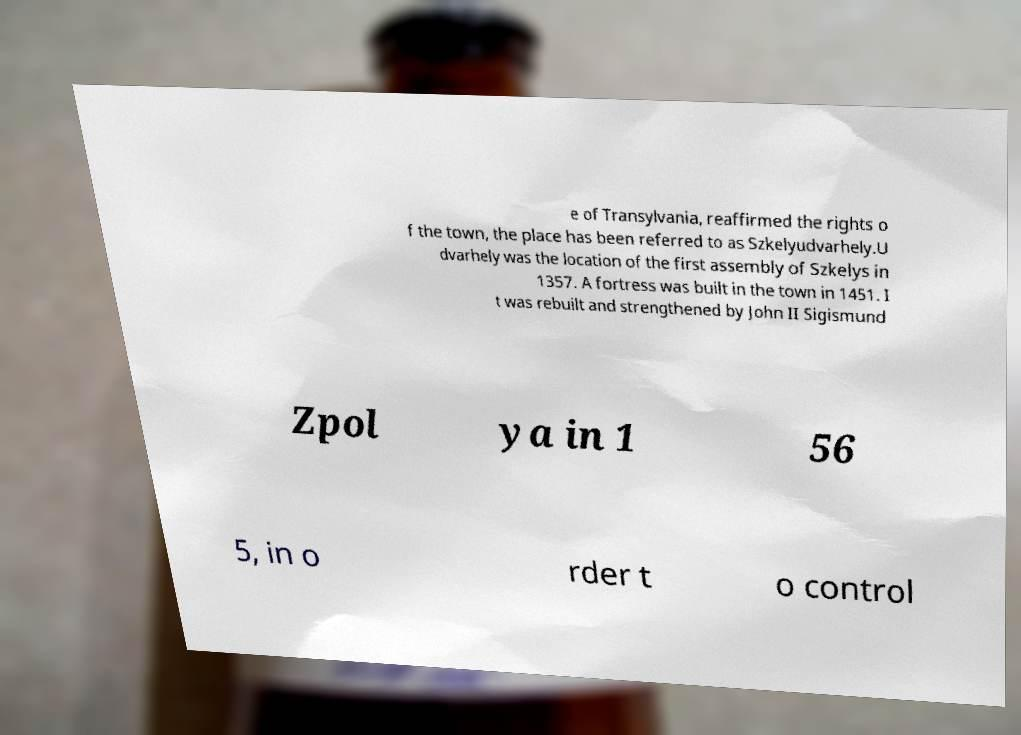For documentation purposes, I need the text within this image transcribed. Could you provide that? e of Transylvania, reaffirmed the rights o f the town, the place has been referred to as Szkelyudvarhely.U dvarhely was the location of the first assembly of Szkelys in 1357. A fortress was built in the town in 1451. I t was rebuilt and strengthened by John II Sigismund Zpol ya in 1 56 5, in o rder t o control 